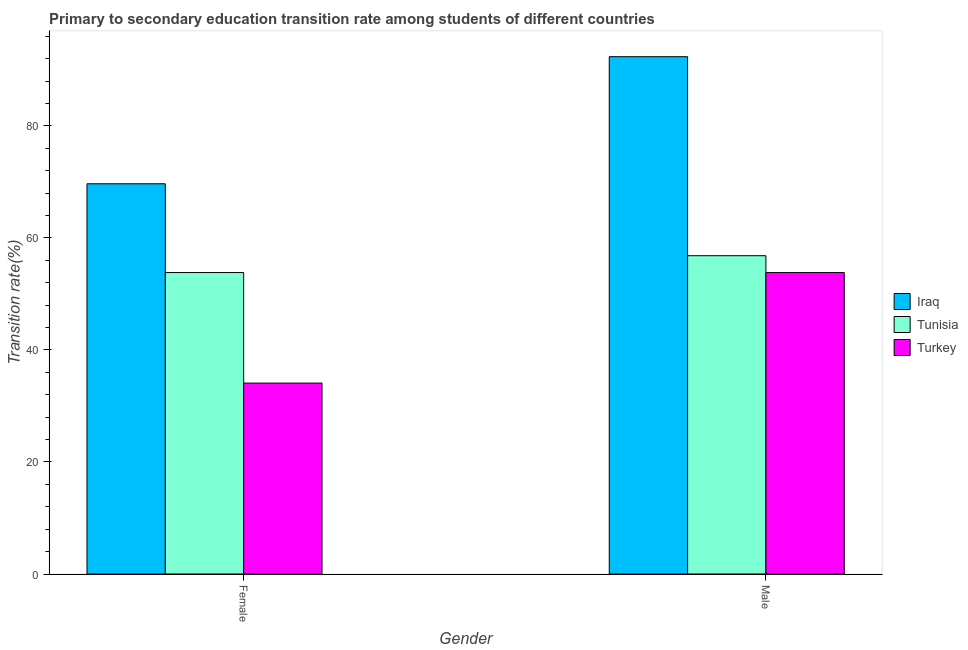Are the number of bars per tick equal to the number of legend labels?
Your response must be concise. Yes. Are the number of bars on each tick of the X-axis equal?
Provide a succinct answer. Yes. How many bars are there on the 1st tick from the left?
Make the answer very short. 3. How many bars are there on the 2nd tick from the right?
Offer a very short reply. 3. What is the label of the 1st group of bars from the left?
Your answer should be very brief. Female. What is the transition rate among female students in Iraq?
Ensure brevity in your answer.  69.68. Across all countries, what is the maximum transition rate among female students?
Give a very brief answer. 69.68. Across all countries, what is the minimum transition rate among female students?
Provide a succinct answer. 34.09. In which country was the transition rate among female students maximum?
Your response must be concise. Iraq. What is the total transition rate among female students in the graph?
Provide a short and direct response. 157.59. What is the difference between the transition rate among female students in Turkey and that in Tunisia?
Your answer should be very brief. -19.74. What is the difference between the transition rate among female students in Iraq and the transition rate among male students in Tunisia?
Your response must be concise. 12.84. What is the average transition rate among female students per country?
Keep it short and to the point. 52.53. What is the difference between the transition rate among female students and transition rate among male students in Iraq?
Provide a succinct answer. -22.69. In how many countries, is the transition rate among male students greater than 8 %?
Provide a succinct answer. 3. What is the ratio of the transition rate among female students in Iraq to that in Turkey?
Your response must be concise. 2.04. What does the 2nd bar from the left in Male represents?
Make the answer very short. Tunisia. What does the 1st bar from the right in Female represents?
Your response must be concise. Turkey. Are the values on the major ticks of Y-axis written in scientific E-notation?
Ensure brevity in your answer.  No. Does the graph contain any zero values?
Your answer should be compact. No. Where does the legend appear in the graph?
Your answer should be very brief. Center right. How many legend labels are there?
Offer a terse response. 3. What is the title of the graph?
Offer a very short reply. Primary to secondary education transition rate among students of different countries. Does "Ethiopia" appear as one of the legend labels in the graph?
Give a very brief answer. No. What is the label or title of the X-axis?
Offer a terse response. Gender. What is the label or title of the Y-axis?
Make the answer very short. Transition rate(%). What is the Transition rate(%) of Iraq in Female?
Your answer should be very brief. 69.68. What is the Transition rate(%) of Tunisia in Female?
Ensure brevity in your answer.  53.82. What is the Transition rate(%) of Turkey in Female?
Provide a short and direct response. 34.09. What is the Transition rate(%) of Iraq in Male?
Ensure brevity in your answer.  92.37. What is the Transition rate(%) in Tunisia in Male?
Make the answer very short. 56.83. What is the Transition rate(%) in Turkey in Male?
Give a very brief answer. 53.82. Across all Gender, what is the maximum Transition rate(%) in Iraq?
Offer a terse response. 92.37. Across all Gender, what is the maximum Transition rate(%) in Tunisia?
Provide a succinct answer. 56.83. Across all Gender, what is the maximum Transition rate(%) in Turkey?
Offer a very short reply. 53.82. Across all Gender, what is the minimum Transition rate(%) of Iraq?
Ensure brevity in your answer.  69.68. Across all Gender, what is the minimum Transition rate(%) in Tunisia?
Your response must be concise. 53.82. Across all Gender, what is the minimum Transition rate(%) of Turkey?
Provide a succinct answer. 34.09. What is the total Transition rate(%) of Iraq in the graph?
Offer a very short reply. 162.04. What is the total Transition rate(%) in Tunisia in the graph?
Your answer should be compact. 110.66. What is the total Transition rate(%) of Turkey in the graph?
Make the answer very short. 87.91. What is the difference between the Transition rate(%) of Iraq in Female and that in Male?
Your response must be concise. -22.69. What is the difference between the Transition rate(%) of Tunisia in Female and that in Male?
Your answer should be compact. -3.01. What is the difference between the Transition rate(%) of Turkey in Female and that in Male?
Make the answer very short. -19.73. What is the difference between the Transition rate(%) in Iraq in Female and the Transition rate(%) in Tunisia in Male?
Give a very brief answer. 12.84. What is the difference between the Transition rate(%) in Iraq in Female and the Transition rate(%) in Turkey in Male?
Your response must be concise. 15.86. What is the difference between the Transition rate(%) in Tunisia in Female and the Transition rate(%) in Turkey in Male?
Your answer should be compact. 0.01. What is the average Transition rate(%) of Iraq per Gender?
Your response must be concise. 81.02. What is the average Transition rate(%) in Tunisia per Gender?
Keep it short and to the point. 55.33. What is the average Transition rate(%) of Turkey per Gender?
Your answer should be compact. 43.95. What is the difference between the Transition rate(%) in Iraq and Transition rate(%) in Tunisia in Female?
Your answer should be very brief. 15.85. What is the difference between the Transition rate(%) in Iraq and Transition rate(%) in Turkey in Female?
Ensure brevity in your answer.  35.59. What is the difference between the Transition rate(%) in Tunisia and Transition rate(%) in Turkey in Female?
Keep it short and to the point. 19.74. What is the difference between the Transition rate(%) of Iraq and Transition rate(%) of Tunisia in Male?
Offer a terse response. 35.54. What is the difference between the Transition rate(%) in Iraq and Transition rate(%) in Turkey in Male?
Offer a very short reply. 38.55. What is the difference between the Transition rate(%) in Tunisia and Transition rate(%) in Turkey in Male?
Your answer should be compact. 3.01. What is the ratio of the Transition rate(%) in Iraq in Female to that in Male?
Your answer should be compact. 0.75. What is the ratio of the Transition rate(%) in Tunisia in Female to that in Male?
Give a very brief answer. 0.95. What is the ratio of the Transition rate(%) in Turkey in Female to that in Male?
Your answer should be compact. 0.63. What is the difference between the highest and the second highest Transition rate(%) in Iraq?
Make the answer very short. 22.69. What is the difference between the highest and the second highest Transition rate(%) of Tunisia?
Your answer should be very brief. 3.01. What is the difference between the highest and the second highest Transition rate(%) in Turkey?
Provide a short and direct response. 19.73. What is the difference between the highest and the lowest Transition rate(%) in Iraq?
Provide a succinct answer. 22.69. What is the difference between the highest and the lowest Transition rate(%) in Tunisia?
Provide a succinct answer. 3.01. What is the difference between the highest and the lowest Transition rate(%) of Turkey?
Provide a succinct answer. 19.73. 